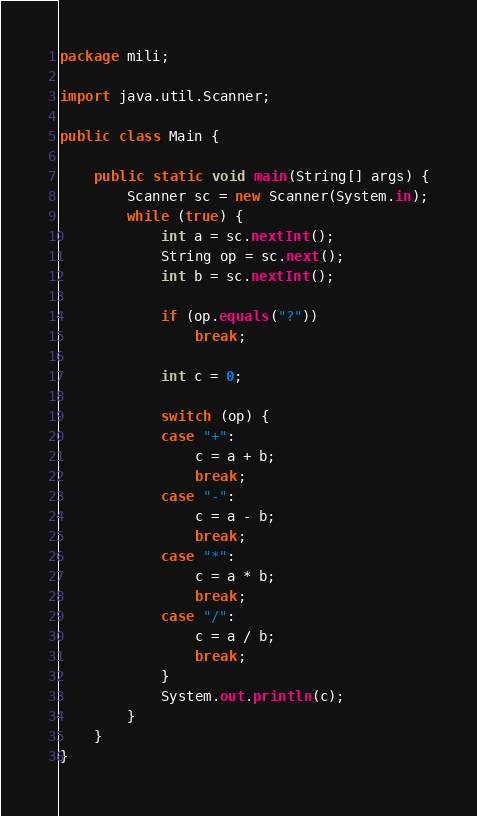<code> <loc_0><loc_0><loc_500><loc_500><_Java_>package mili;

import java.util.Scanner;

public class Main {

	public static void main(String[] args) {
		Scanner sc = new Scanner(System.in);
		while (true) {
			int a = sc.nextInt();
			String op = sc.next();
			int b = sc.nextInt();

			if (op.equals("?"))
				break;

			int c = 0;

			switch (op) {
			case "+":
				c = a + b;
				break;
			case "-":
				c = a - b;
				break;
			case "*":
				c = a * b;
				break;
			case "/":
				c = a / b;
				break;
			}
			System.out.println(c);
		}
	}
}
</code> 